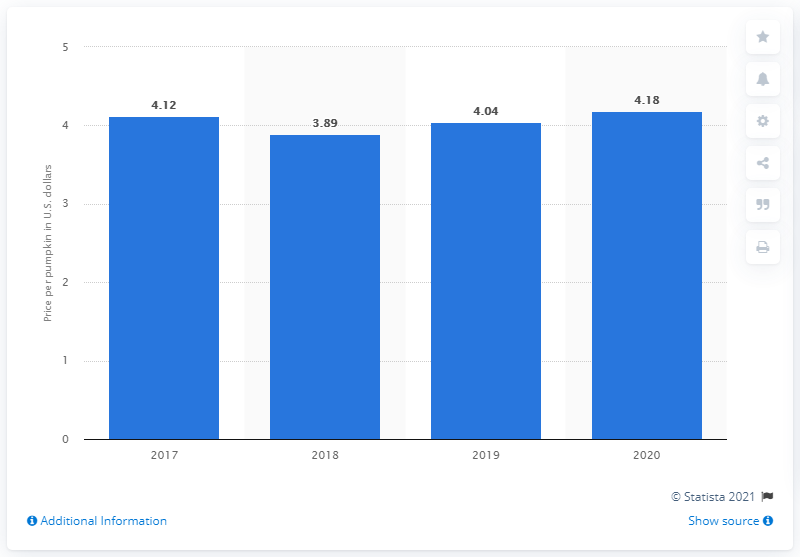Specify some key components in this picture. According to data from 2020, the average price per pumpkin in the United States was 4.18 dollars. 